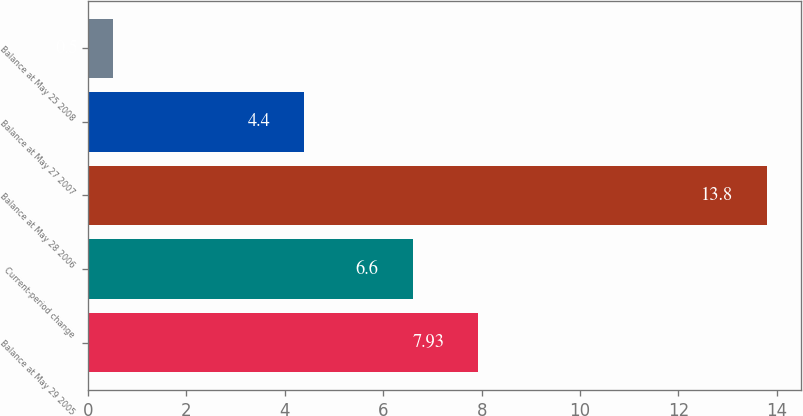Convert chart to OTSL. <chart><loc_0><loc_0><loc_500><loc_500><bar_chart><fcel>Balance at May 29 2005<fcel>Current-period change<fcel>Balance at May 28 2006<fcel>Balance at May 27 2007<fcel>Balance at May 25 2008<nl><fcel>7.93<fcel>6.6<fcel>13.8<fcel>4.4<fcel>0.5<nl></chart> 